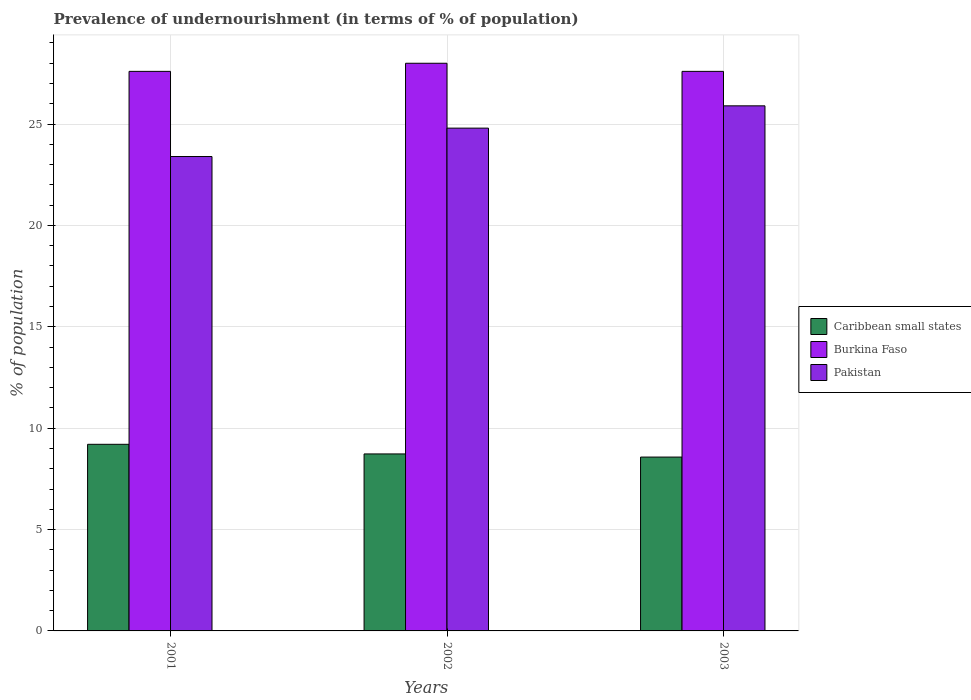How many different coloured bars are there?
Your answer should be compact. 3. Are the number of bars per tick equal to the number of legend labels?
Provide a short and direct response. Yes. What is the label of the 1st group of bars from the left?
Make the answer very short. 2001. What is the percentage of undernourished population in Caribbean small states in 2002?
Give a very brief answer. 8.73. Across all years, what is the maximum percentage of undernourished population in Pakistan?
Your response must be concise. 25.9. Across all years, what is the minimum percentage of undernourished population in Burkina Faso?
Make the answer very short. 27.6. In which year was the percentage of undernourished population in Caribbean small states maximum?
Keep it short and to the point. 2001. What is the total percentage of undernourished population in Caribbean small states in the graph?
Keep it short and to the point. 26.51. What is the difference between the percentage of undernourished population in Pakistan in 2001 and that in 2003?
Provide a succinct answer. -2.5. What is the difference between the percentage of undernourished population in Pakistan in 2003 and the percentage of undernourished population in Caribbean small states in 2001?
Your answer should be compact. 16.69. What is the average percentage of undernourished population in Burkina Faso per year?
Keep it short and to the point. 27.73. In the year 2002, what is the difference between the percentage of undernourished population in Pakistan and percentage of undernourished population in Caribbean small states?
Your response must be concise. 16.07. What is the ratio of the percentage of undernourished population in Caribbean small states in 2001 to that in 2002?
Offer a terse response. 1.05. Is the percentage of undernourished population in Caribbean small states in 2001 less than that in 2003?
Ensure brevity in your answer.  No. Is the difference between the percentage of undernourished population in Pakistan in 2001 and 2003 greater than the difference between the percentage of undernourished population in Caribbean small states in 2001 and 2003?
Your response must be concise. No. What is the difference between the highest and the second highest percentage of undernourished population in Pakistan?
Offer a very short reply. 1.1. What is the difference between the highest and the lowest percentage of undernourished population in Caribbean small states?
Ensure brevity in your answer.  0.63. What does the 2nd bar from the left in 2003 represents?
Make the answer very short. Burkina Faso. What does the 2nd bar from the right in 2003 represents?
Keep it short and to the point. Burkina Faso. Are all the bars in the graph horizontal?
Give a very brief answer. No. How many years are there in the graph?
Ensure brevity in your answer.  3. Are the values on the major ticks of Y-axis written in scientific E-notation?
Ensure brevity in your answer.  No. Where does the legend appear in the graph?
Your answer should be compact. Center right. How many legend labels are there?
Provide a short and direct response. 3. How are the legend labels stacked?
Your answer should be compact. Vertical. What is the title of the graph?
Your answer should be compact. Prevalence of undernourishment (in terms of % of population). Does "United Arab Emirates" appear as one of the legend labels in the graph?
Keep it short and to the point. No. What is the label or title of the X-axis?
Ensure brevity in your answer.  Years. What is the label or title of the Y-axis?
Provide a short and direct response. % of population. What is the % of population of Caribbean small states in 2001?
Offer a very short reply. 9.21. What is the % of population of Burkina Faso in 2001?
Provide a succinct answer. 27.6. What is the % of population of Pakistan in 2001?
Make the answer very short. 23.4. What is the % of population in Caribbean small states in 2002?
Your response must be concise. 8.73. What is the % of population in Pakistan in 2002?
Ensure brevity in your answer.  24.8. What is the % of population in Caribbean small states in 2003?
Offer a terse response. 8.57. What is the % of population in Burkina Faso in 2003?
Provide a succinct answer. 27.6. What is the % of population in Pakistan in 2003?
Your response must be concise. 25.9. Across all years, what is the maximum % of population of Caribbean small states?
Give a very brief answer. 9.21. Across all years, what is the maximum % of population of Burkina Faso?
Your answer should be compact. 28. Across all years, what is the maximum % of population in Pakistan?
Give a very brief answer. 25.9. Across all years, what is the minimum % of population in Caribbean small states?
Make the answer very short. 8.57. Across all years, what is the minimum % of population of Burkina Faso?
Provide a succinct answer. 27.6. Across all years, what is the minimum % of population of Pakistan?
Provide a succinct answer. 23.4. What is the total % of population in Caribbean small states in the graph?
Give a very brief answer. 26.51. What is the total % of population in Burkina Faso in the graph?
Keep it short and to the point. 83.2. What is the total % of population of Pakistan in the graph?
Your answer should be compact. 74.1. What is the difference between the % of population of Caribbean small states in 2001 and that in 2002?
Your response must be concise. 0.47. What is the difference between the % of population in Burkina Faso in 2001 and that in 2002?
Make the answer very short. -0.4. What is the difference between the % of population in Caribbean small states in 2001 and that in 2003?
Give a very brief answer. 0.63. What is the difference between the % of population in Burkina Faso in 2001 and that in 2003?
Your answer should be very brief. 0. What is the difference between the % of population in Caribbean small states in 2002 and that in 2003?
Offer a very short reply. 0.16. What is the difference between the % of population of Pakistan in 2002 and that in 2003?
Ensure brevity in your answer.  -1.1. What is the difference between the % of population of Caribbean small states in 2001 and the % of population of Burkina Faso in 2002?
Your answer should be compact. -18.8. What is the difference between the % of population of Caribbean small states in 2001 and the % of population of Pakistan in 2002?
Ensure brevity in your answer.  -15.6. What is the difference between the % of population of Caribbean small states in 2001 and the % of population of Burkina Faso in 2003?
Your answer should be compact. -18.39. What is the difference between the % of population of Caribbean small states in 2001 and the % of population of Pakistan in 2003?
Provide a succinct answer. -16.7. What is the difference between the % of population in Caribbean small states in 2002 and the % of population in Burkina Faso in 2003?
Make the answer very short. -18.87. What is the difference between the % of population in Caribbean small states in 2002 and the % of population in Pakistan in 2003?
Ensure brevity in your answer.  -17.17. What is the difference between the % of population of Burkina Faso in 2002 and the % of population of Pakistan in 2003?
Provide a succinct answer. 2.1. What is the average % of population of Caribbean small states per year?
Ensure brevity in your answer.  8.84. What is the average % of population of Burkina Faso per year?
Provide a succinct answer. 27.73. What is the average % of population of Pakistan per year?
Make the answer very short. 24.7. In the year 2001, what is the difference between the % of population of Caribbean small states and % of population of Burkina Faso?
Offer a very short reply. -18.39. In the year 2001, what is the difference between the % of population of Caribbean small states and % of population of Pakistan?
Your answer should be very brief. -14.2. In the year 2002, what is the difference between the % of population in Caribbean small states and % of population in Burkina Faso?
Provide a short and direct response. -19.27. In the year 2002, what is the difference between the % of population of Caribbean small states and % of population of Pakistan?
Keep it short and to the point. -16.07. In the year 2003, what is the difference between the % of population of Caribbean small states and % of population of Burkina Faso?
Provide a short and direct response. -19.03. In the year 2003, what is the difference between the % of population in Caribbean small states and % of population in Pakistan?
Your response must be concise. -17.33. In the year 2003, what is the difference between the % of population of Burkina Faso and % of population of Pakistan?
Give a very brief answer. 1.7. What is the ratio of the % of population of Caribbean small states in 2001 to that in 2002?
Offer a terse response. 1.05. What is the ratio of the % of population of Burkina Faso in 2001 to that in 2002?
Provide a short and direct response. 0.99. What is the ratio of the % of population of Pakistan in 2001 to that in 2002?
Your response must be concise. 0.94. What is the ratio of the % of population in Caribbean small states in 2001 to that in 2003?
Your response must be concise. 1.07. What is the ratio of the % of population of Pakistan in 2001 to that in 2003?
Offer a terse response. 0.9. What is the ratio of the % of population of Caribbean small states in 2002 to that in 2003?
Your answer should be very brief. 1.02. What is the ratio of the % of population in Burkina Faso in 2002 to that in 2003?
Give a very brief answer. 1.01. What is the ratio of the % of population in Pakistan in 2002 to that in 2003?
Ensure brevity in your answer.  0.96. What is the difference between the highest and the second highest % of population of Caribbean small states?
Your answer should be compact. 0.47. What is the difference between the highest and the second highest % of population in Burkina Faso?
Your answer should be very brief. 0.4. What is the difference between the highest and the second highest % of population in Pakistan?
Offer a terse response. 1.1. What is the difference between the highest and the lowest % of population in Caribbean small states?
Give a very brief answer. 0.63. 